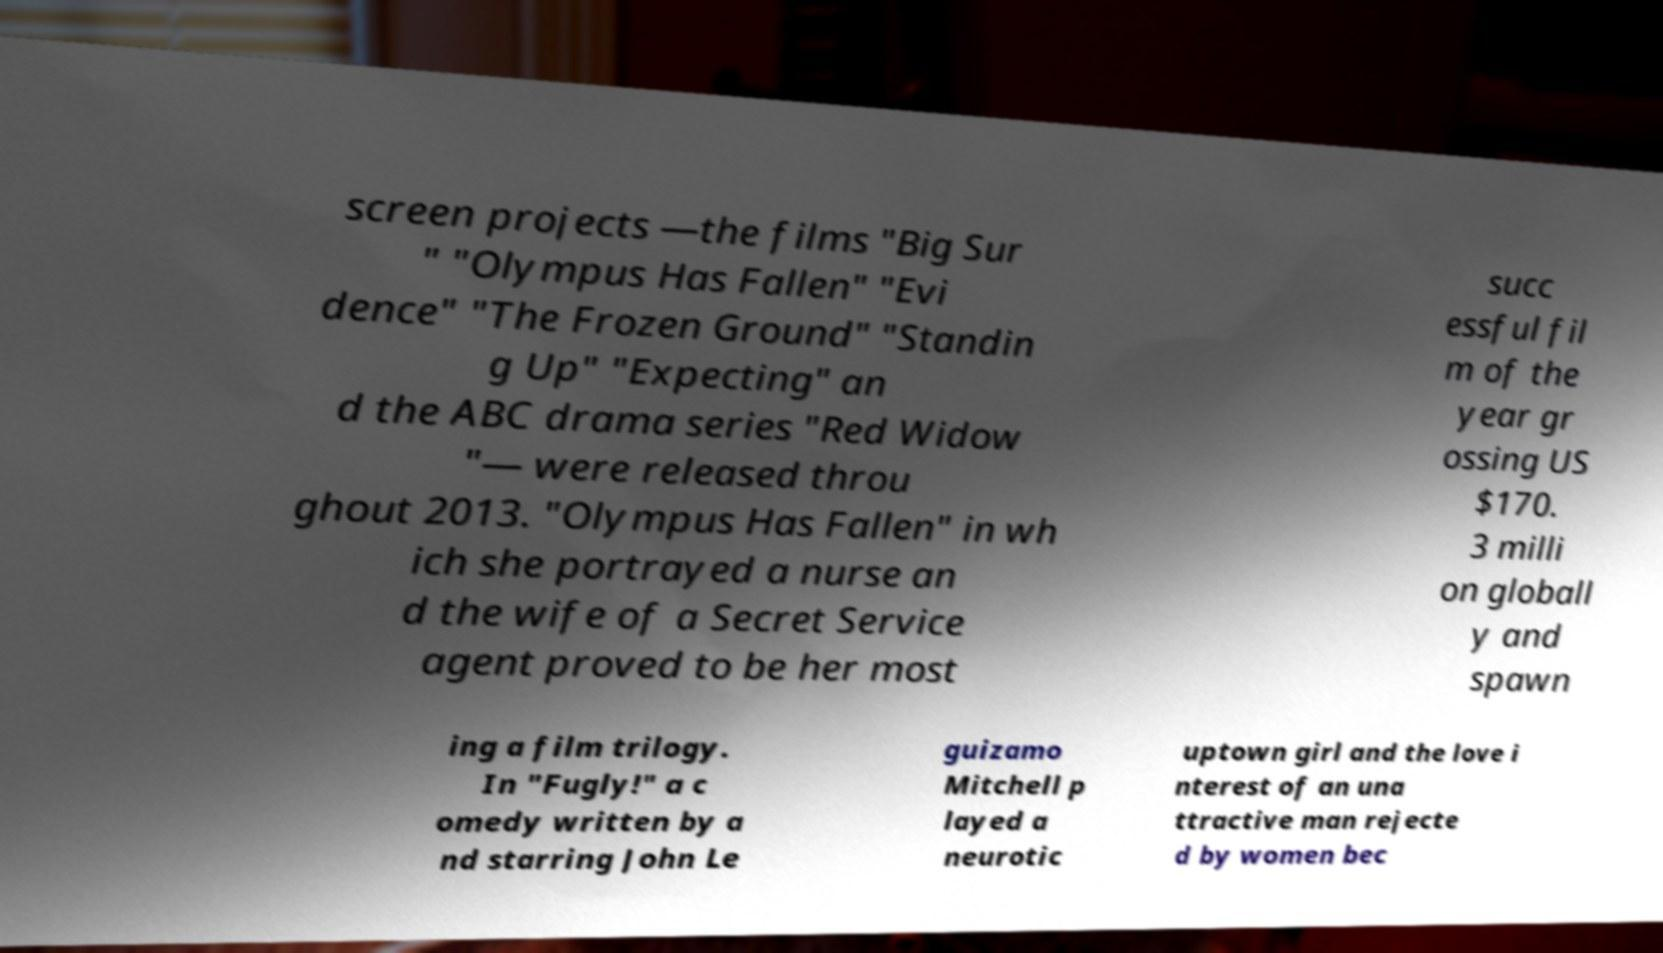There's text embedded in this image that I need extracted. Can you transcribe it verbatim? screen projects —the films "Big Sur " "Olympus Has Fallen" "Evi dence" "The Frozen Ground" "Standin g Up" "Expecting" an d the ABC drama series "Red Widow "— were released throu ghout 2013. "Olympus Has Fallen" in wh ich she portrayed a nurse an d the wife of a Secret Service agent proved to be her most succ essful fil m of the year gr ossing US $170. 3 milli on globall y and spawn ing a film trilogy. In "Fugly!" a c omedy written by a nd starring John Le guizamo Mitchell p layed a neurotic uptown girl and the love i nterest of an una ttractive man rejecte d by women bec 